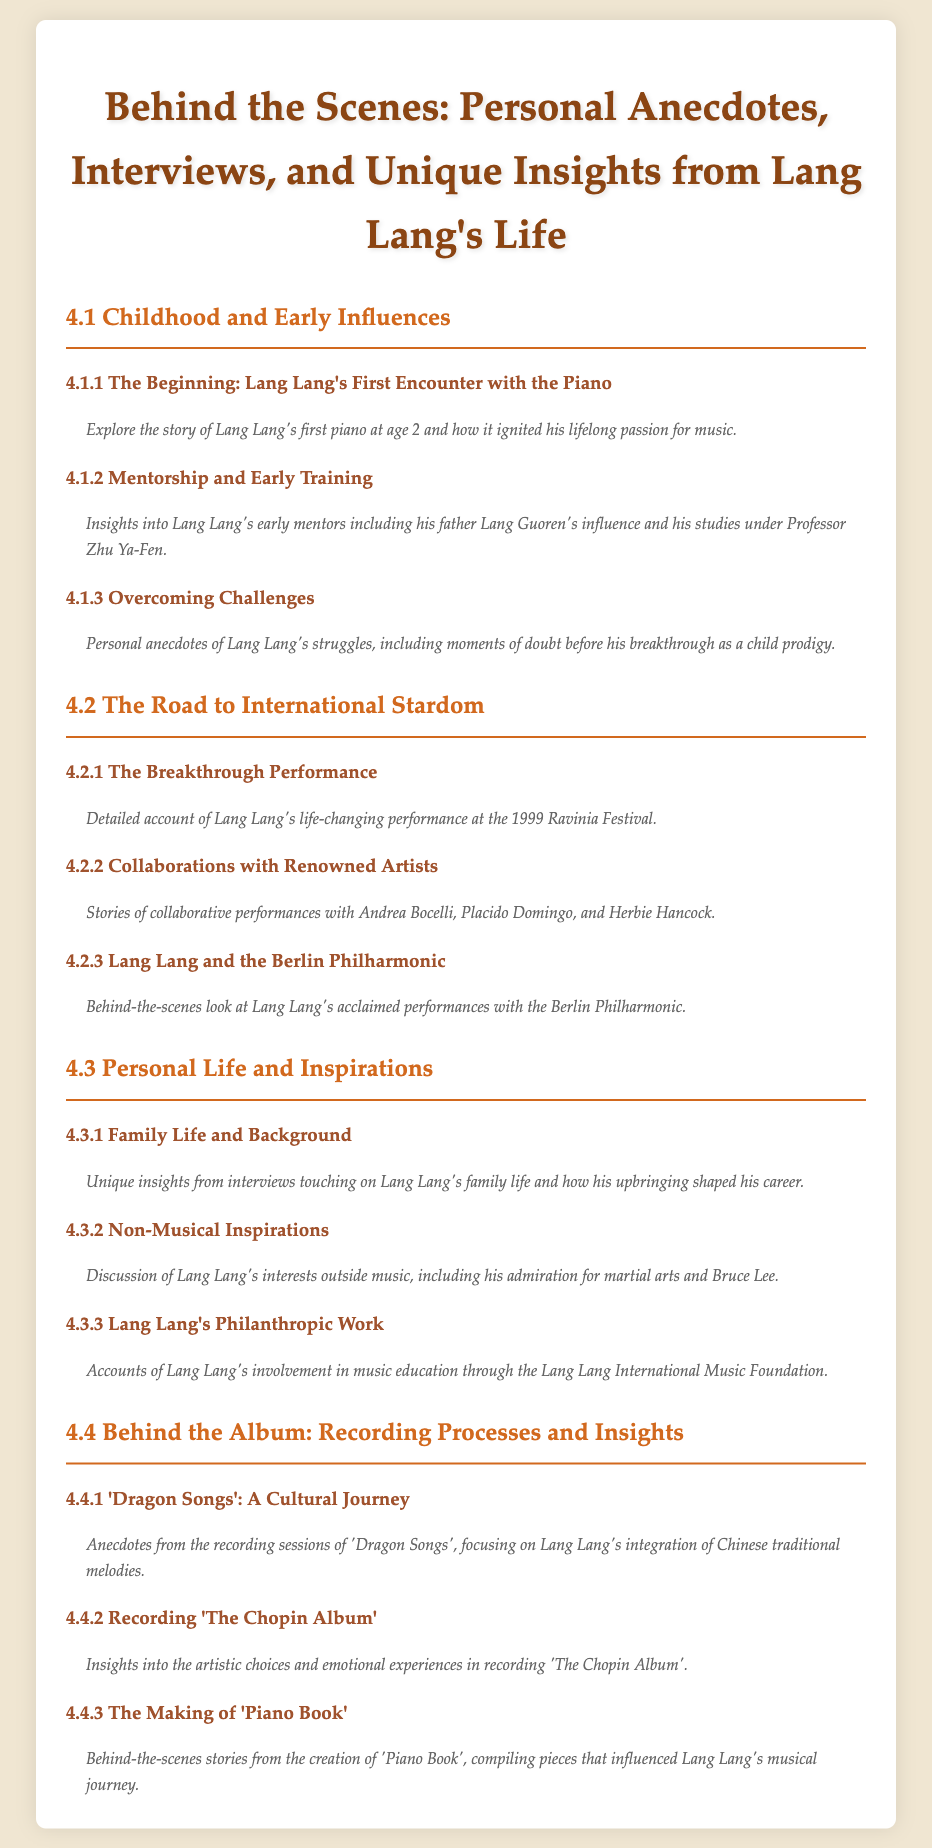What was Lang Lang's first encounter with the piano? The document mentions Lang Lang's first piano at age 2, which ignited his lifelong passion for music.
Answer: Age 2 Who was Lang Lang's father? The document refers to Lang Lang's father's influence, stating his name as Lang Guoren.
Answer: Lang Guoren What notable performance changed Lang Lang's life? The document describes a life-changing performance at the 1999 Ravinia Festival.
Answer: 1999 Ravinia Festival Which artists did Lang Lang collaborate with? The document lists renowned artists such as Andrea Bocelli, Placido Domingo, and Herbie Hancock he collaborated with.
Answer: Andrea Bocelli, Placido Domingo, Herbie Hancock What is the name of the philanthropic foundation Lang Lang is involved with? The document mentions the Lang Lang International Music Foundation related to his involvement in music education.
Answer: Lang Lang International Music Foundation What type of songs are included in 'Dragon Songs'? The document emphasizes the integration of Chinese traditional melodies in the recording sessions of 'Dragon Songs'.
Answer: Chinese traditional melodies What emotions are considered in the recording of 'The Chopin Album'? The document highlights artistic choices and emotional experiences during the recording process for 'The Chopin Album'.
Answer: Artistic choices and emotional experiences In what aspect of life was Lang Lang inspired besides music? The document discusses Lang Lang's admiration for martial arts and Bruce Lee as non-musical inspirations.
Answer: Martial arts and Bruce Lee What was a major theme in the creation of 'Piano Book'? The document states that 'Piano Book' includes pieces that influenced Lang Lang's musical journey.
Answer: Pieces that influenced his musical journey 